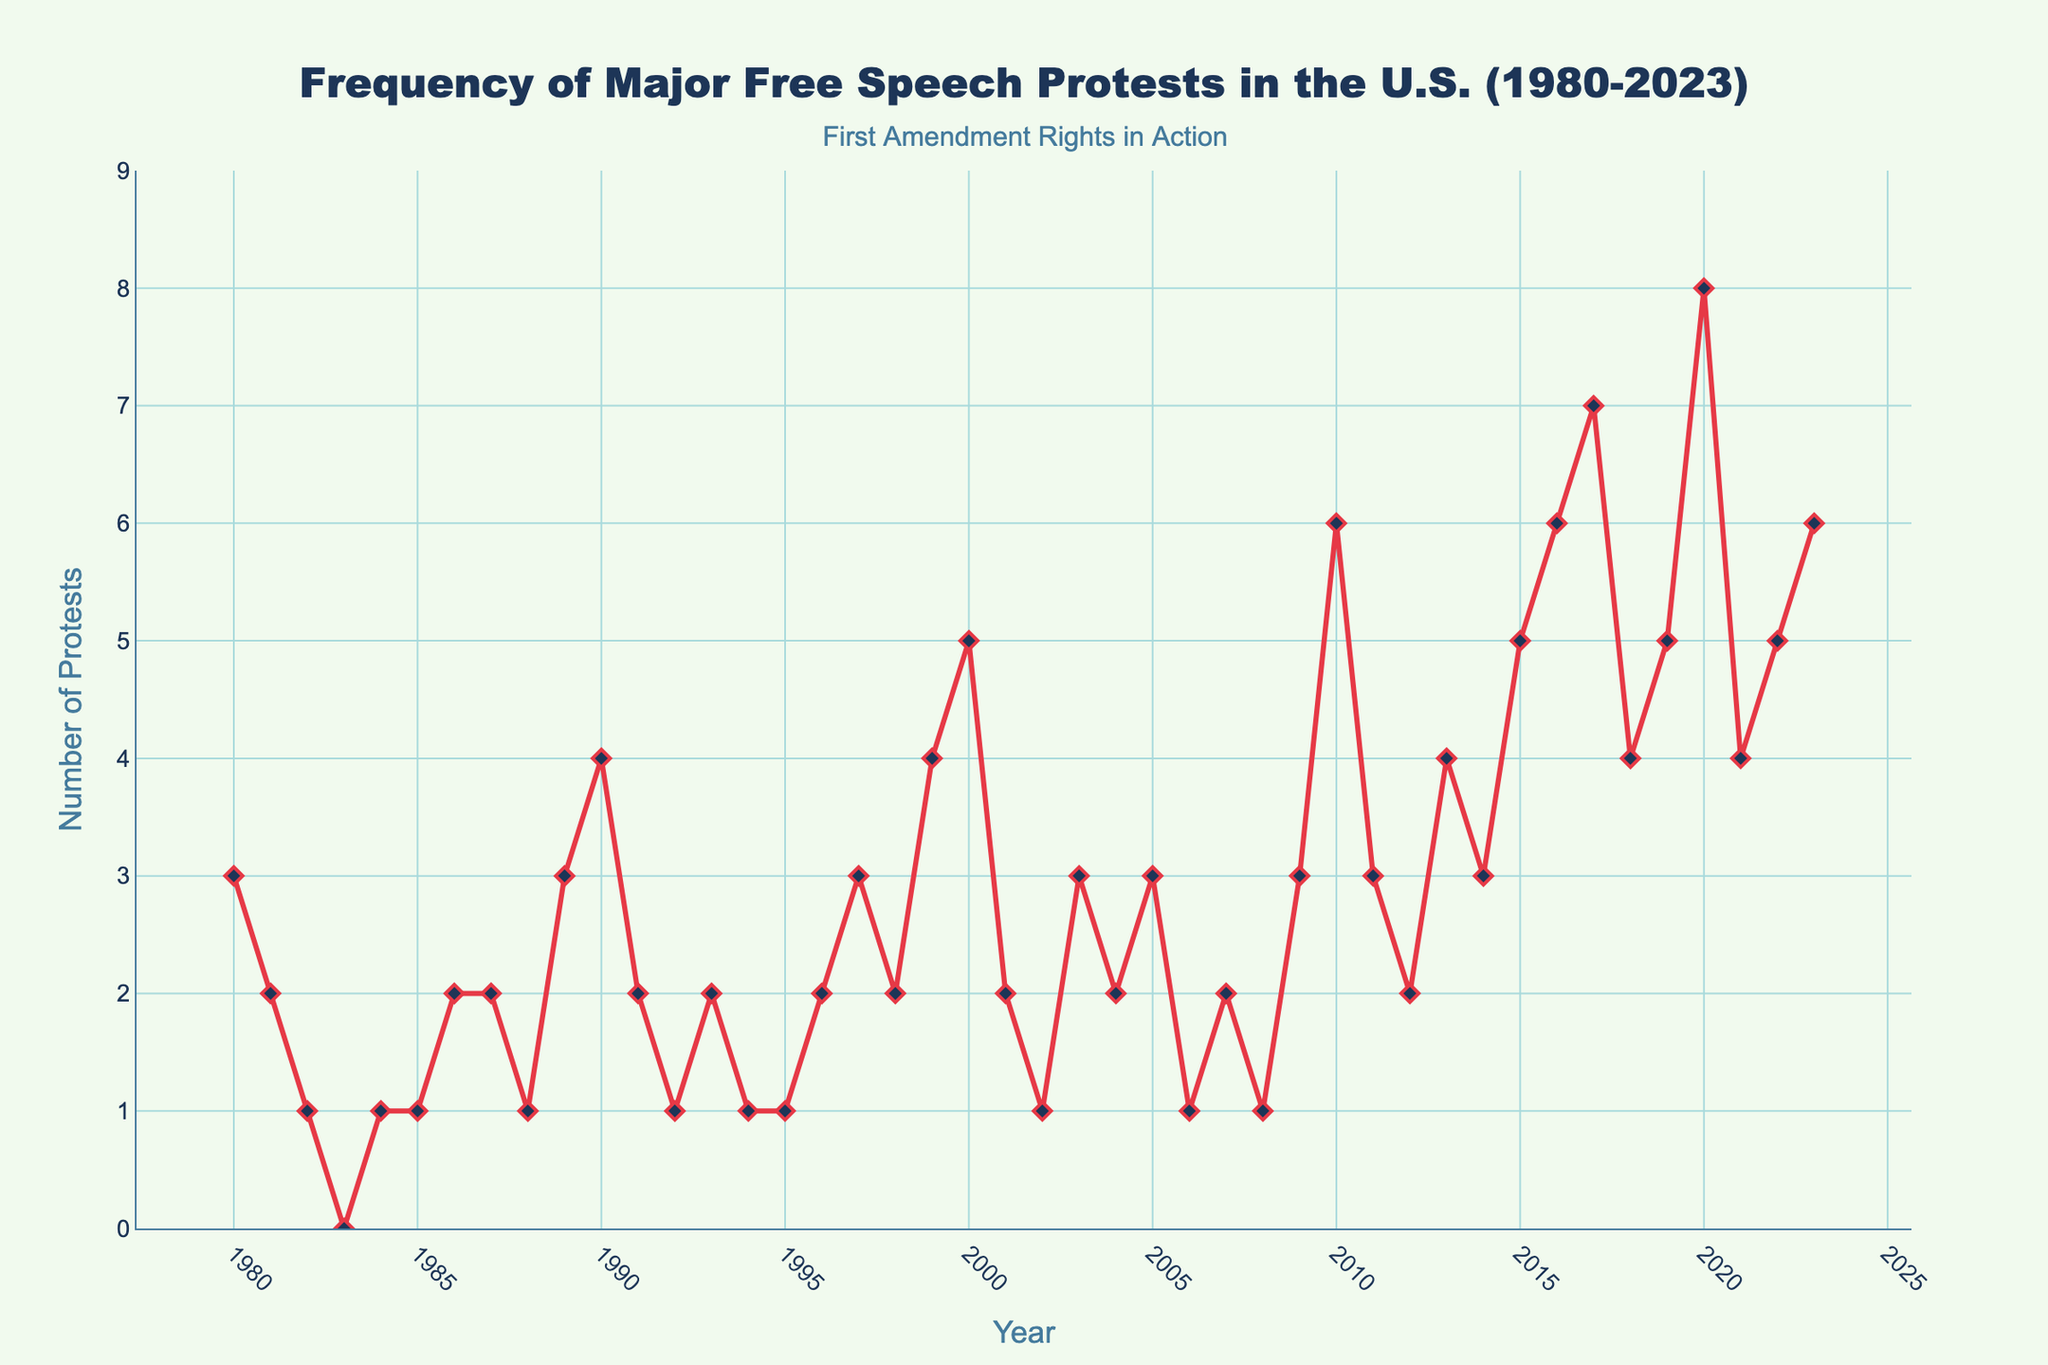What is the title of the plot? The title of the plot can be seen clearly at the top of the figure. The title reads "Frequency of Major Free Speech Protests in the U.S. (1980-2023)".
Answer: Frequency of Major Free Speech Protests in the U.S. (1980-2023) What are the labels for the x-axis and y-axis? The labels for the axes can be found directly below the x-axis and next to the y-axis. The x-axis is labeled "Year" and the y-axis is labeled "Number of Protests".
Answer: Year; Number of Protests Which year has the highest number of major free speech protests? By observing the peaks in the plot and checking the corresponding x-axis values, we can see that the highest peak occurs in 2020.
Answer: 2020 How many protests were recorded in the year 2000? Look for the data point on the plot where the x-axis value is 2000 and find the corresponding y-axis value, which is 5.
Answer: 5 What is the average number of protests per year from 1980 to 1990? Sum all the protests from 1980 to 1990 (3+2+1+0+1+1+2+2+1+3+4) = 20, then divide by the number of years (11).
Answer: 1.82 Find the total number of protests from 2015 to 2020. Add the y-axis values for the years 2015 to 2020: 5 (2015) + 6 (2016) + 7 (2017) + 4 (2018) + 5 (2019) + 8 (2020) = 35.
Answer: 35 In which year did the number of protests increase the most compared to the previous year? To find the year with the largest increase, calculate the differences for each year and identify the maximum. The largest difference is from 2019 to 2020, where the count increased from 5 to 8.
Answer: 2020 How does the number of protests in 2023 compare to that in 1980? Locate each year on the x-axis and compare the y-axis values. 1980 has 3 protests whereas 2023 has 6 protests. 2023 has twice as many protests as 1980.
Answer: 6 is greater than 3 What is the trend of the number of protests from 2015 to 2020? Observe the plot's line from 2015 to 2020. The number of protests generally increases over these years.
Answer: Increasing Is there a year with an absolute count of zero protests? Look for any point where the y-axis value is zero. The year 1983 has an absolute count of zero protests.
Answer: 1983 